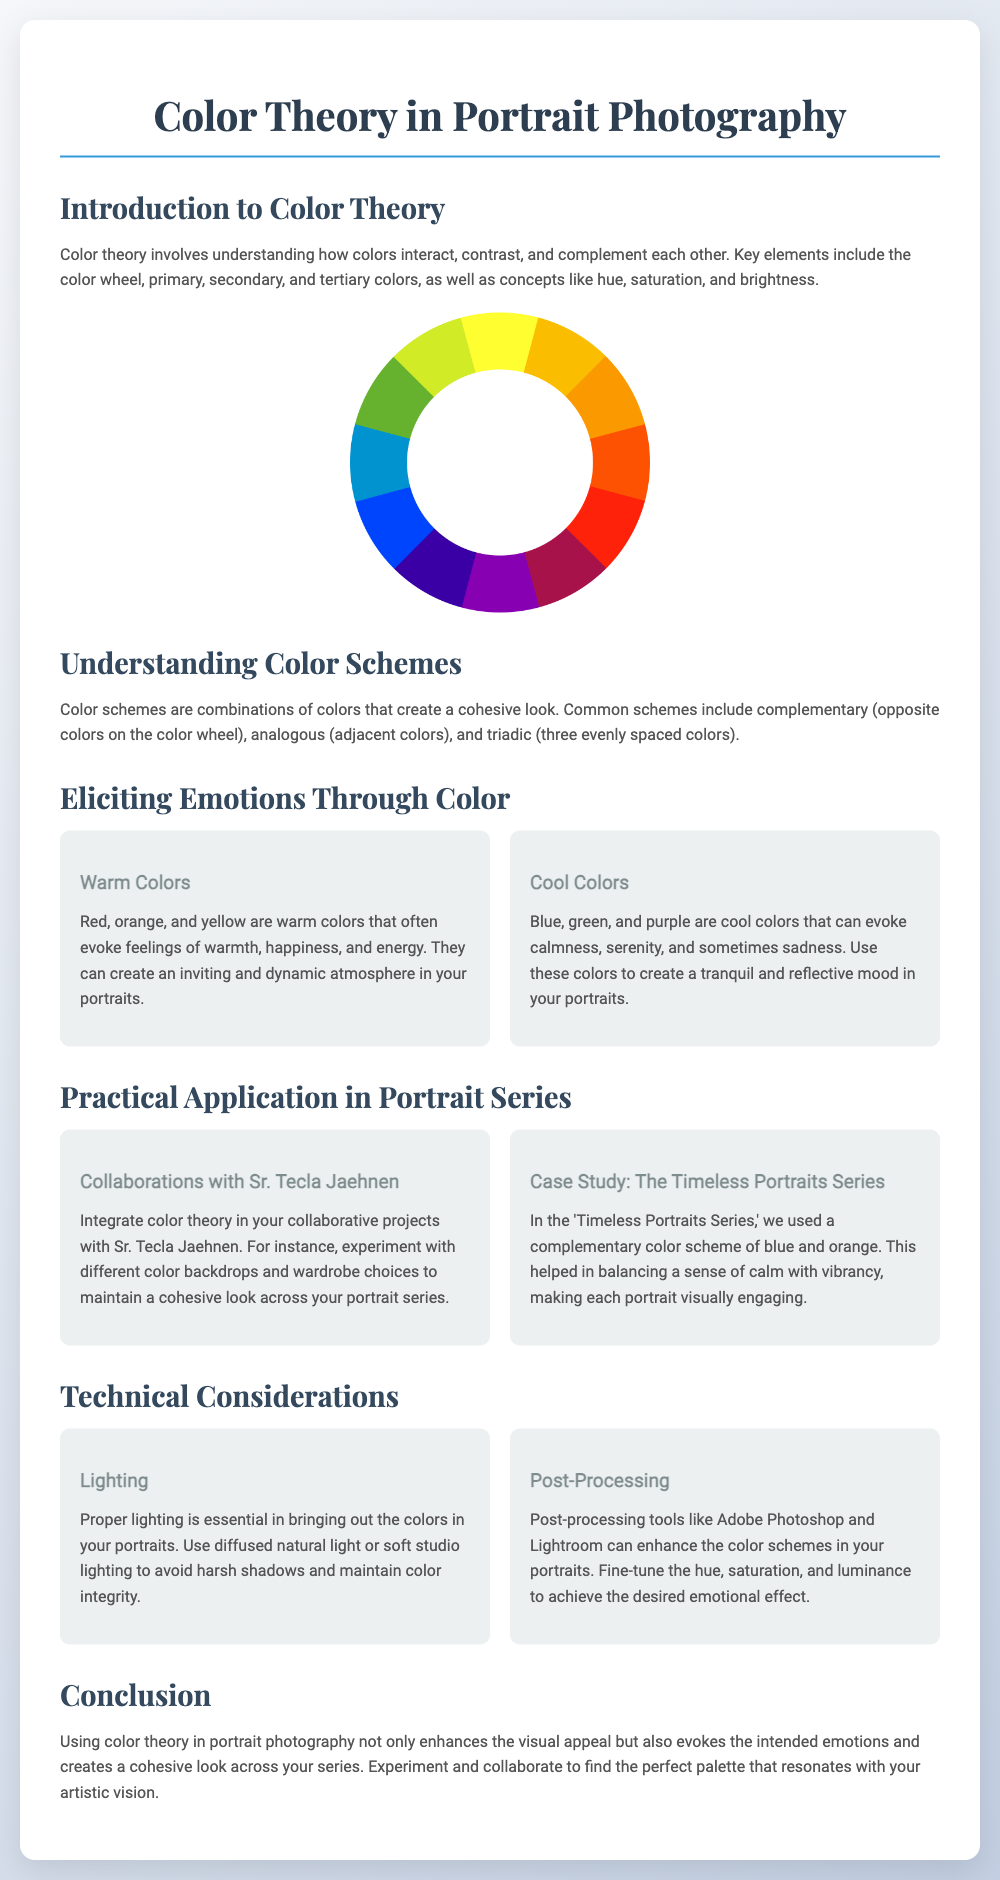What are the primary colors? The primary colors are red, blue, and yellow, which are fundamental in creating other colors.
Answer: Red, blue, yellow What color schemes are mentioned? The document lists three common color schemes in portrait photography: complementary, analogous, and triadic.
Answer: Complementary, analogous, triadic What emotions do warm colors evoke? Warm colors like red, orange, and yellow are associated with feelings of warmth, happiness, and energy.
Answer: Warmth, happiness, energy What lighting is recommended for portraits? The document advises using diffused natural light or soft studio lighting to maintain color integrity.
Answer: Diffused natural light Which color scheme was used in the 'Timeless Portraits Series'? The document states that a complementary color scheme of blue and orange was used in that series.
Answer: Blue and orange Who is Sr. Tecla Jaehnen? Sr. Tecla Jaehnen is mentioned as a collaborator in creative projects involving color theory.
Answer: A collaborator What is the purpose of post-processing in portrait photography? Post-processing tools enhance the color schemes and help to fine-tune the emotional impact of the portraits.
Answer: Enhance color schemes How many content boxes are in the 'Eliciting Emotions Through Color' section? The section contains two content boxes, one for warm colors and one for cool colors.
Answer: Two What key element is involved in understanding color theory? The color wheel is a key element mentioned in understanding how colors interact with each other.
Answer: Color wheel 